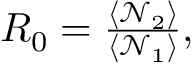Convert formula to latex. <formula><loc_0><loc_0><loc_500><loc_500>\begin{array} { r } { R _ { 0 } = \frac { \langle \mathcal { N } _ { 2 } \rangle } { \langle \mathcal { N } _ { 1 } \rangle } , } \end{array}</formula> 